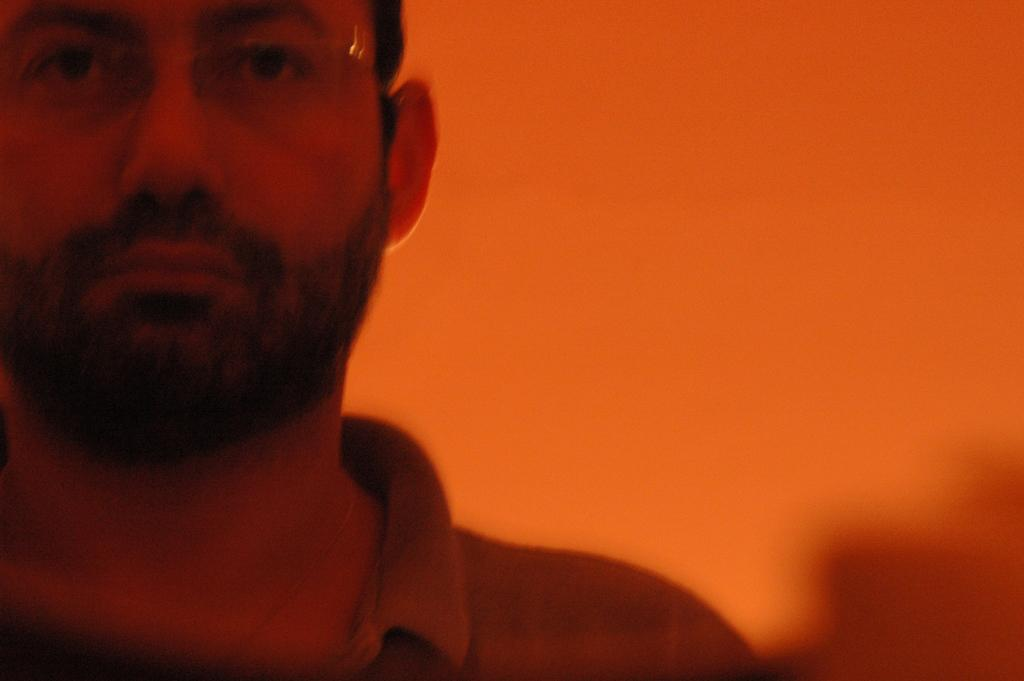Who is present in the image? There is a man in the image. Can you describe the background of the image? The background of the image is blurry. What type of dress is the man wearing in the image? The man is not wearing a dress in the image, as he is a male. 